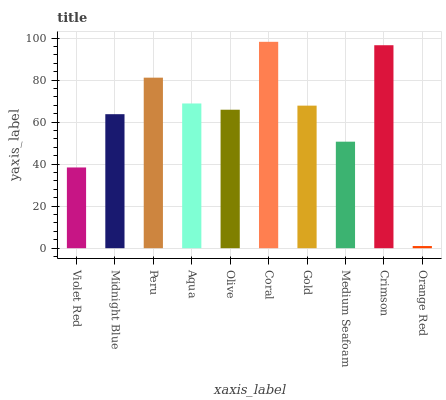Is Orange Red the minimum?
Answer yes or no. Yes. Is Coral the maximum?
Answer yes or no. Yes. Is Midnight Blue the minimum?
Answer yes or no. No. Is Midnight Blue the maximum?
Answer yes or no. No. Is Midnight Blue greater than Violet Red?
Answer yes or no. Yes. Is Violet Red less than Midnight Blue?
Answer yes or no. Yes. Is Violet Red greater than Midnight Blue?
Answer yes or no. No. Is Midnight Blue less than Violet Red?
Answer yes or no. No. Is Gold the high median?
Answer yes or no. Yes. Is Olive the low median?
Answer yes or no. Yes. Is Midnight Blue the high median?
Answer yes or no. No. Is Midnight Blue the low median?
Answer yes or no. No. 